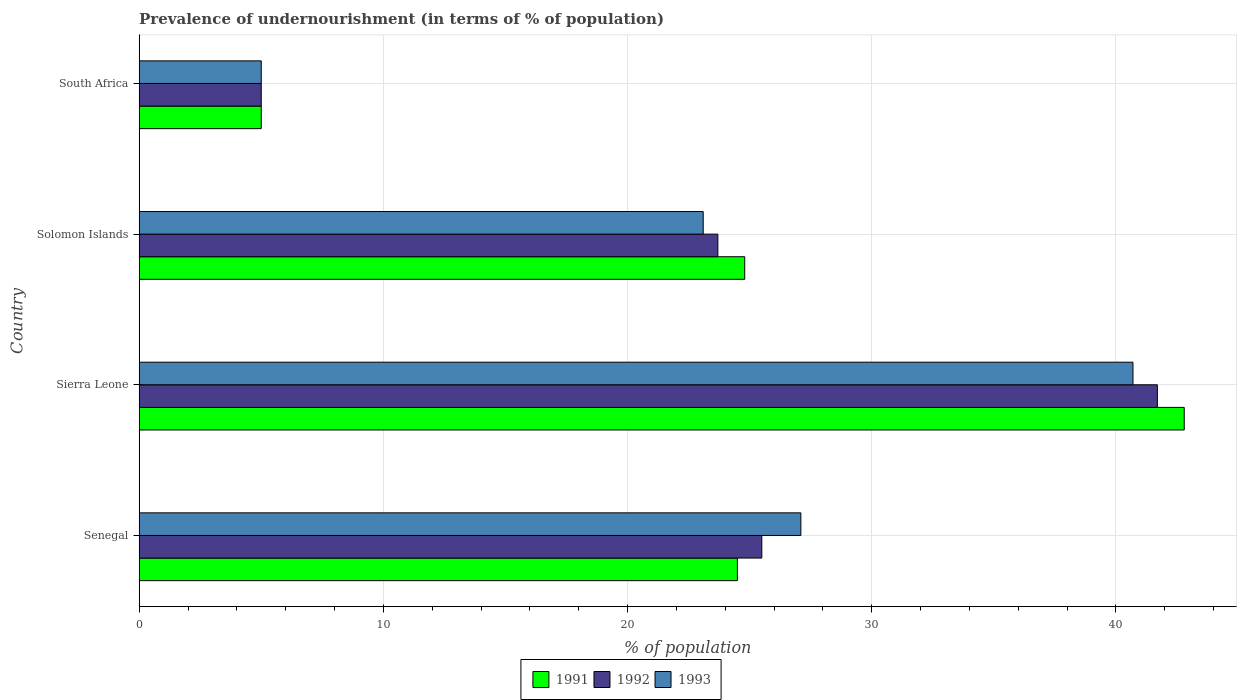How many different coloured bars are there?
Make the answer very short. 3. How many groups of bars are there?
Your answer should be very brief. 4. Are the number of bars on each tick of the Y-axis equal?
Your answer should be very brief. Yes. How many bars are there on the 2nd tick from the top?
Make the answer very short. 3. What is the label of the 3rd group of bars from the top?
Your response must be concise. Sierra Leone. What is the percentage of undernourished population in 1992 in Solomon Islands?
Offer a very short reply. 23.7. Across all countries, what is the maximum percentage of undernourished population in 1991?
Give a very brief answer. 42.8. Across all countries, what is the minimum percentage of undernourished population in 1993?
Offer a very short reply. 5. In which country was the percentage of undernourished population in 1993 maximum?
Offer a very short reply. Sierra Leone. In which country was the percentage of undernourished population in 1992 minimum?
Offer a terse response. South Africa. What is the total percentage of undernourished population in 1991 in the graph?
Keep it short and to the point. 97.1. What is the difference between the percentage of undernourished population in 1991 in Sierra Leone and the percentage of undernourished population in 1993 in Senegal?
Your answer should be very brief. 15.7. What is the average percentage of undernourished population in 1992 per country?
Offer a very short reply. 23.98. What is the difference between the percentage of undernourished population in 1991 and percentage of undernourished population in 1993 in Solomon Islands?
Give a very brief answer. 1.7. In how many countries, is the percentage of undernourished population in 1992 greater than 36 %?
Make the answer very short. 1. What is the ratio of the percentage of undernourished population in 1991 in Senegal to that in Sierra Leone?
Make the answer very short. 0.57. Is the percentage of undernourished population in 1992 in Senegal less than that in Sierra Leone?
Give a very brief answer. Yes. What is the difference between the highest and the second highest percentage of undernourished population in 1993?
Keep it short and to the point. 13.6. What is the difference between the highest and the lowest percentage of undernourished population in 1993?
Keep it short and to the point. 35.7. What does the 3rd bar from the bottom in Sierra Leone represents?
Your answer should be compact. 1993. Is it the case that in every country, the sum of the percentage of undernourished population in 1993 and percentage of undernourished population in 1991 is greater than the percentage of undernourished population in 1992?
Your answer should be very brief. Yes. How many bars are there?
Offer a terse response. 12. How many countries are there in the graph?
Your response must be concise. 4. What is the difference between two consecutive major ticks on the X-axis?
Provide a succinct answer. 10. Does the graph contain grids?
Ensure brevity in your answer.  Yes. Where does the legend appear in the graph?
Offer a terse response. Bottom center. How are the legend labels stacked?
Ensure brevity in your answer.  Horizontal. What is the title of the graph?
Provide a succinct answer. Prevalence of undernourishment (in terms of % of population). Does "2003" appear as one of the legend labels in the graph?
Make the answer very short. No. What is the label or title of the X-axis?
Your response must be concise. % of population. What is the % of population in 1992 in Senegal?
Provide a short and direct response. 25.5. What is the % of population of 1993 in Senegal?
Give a very brief answer. 27.1. What is the % of population in 1991 in Sierra Leone?
Give a very brief answer. 42.8. What is the % of population of 1992 in Sierra Leone?
Ensure brevity in your answer.  41.7. What is the % of population in 1993 in Sierra Leone?
Your answer should be compact. 40.7. What is the % of population of 1991 in Solomon Islands?
Provide a succinct answer. 24.8. What is the % of population in 1992 in Solomon Islands?
Your answer should be very brief. 23.7. What is the % of population of 1993 in Solomon Islands?
Your response must be concise. 23.1. Across all countries, what is the maximum % of population in 1991?
Ensure brevity in your answer.  42.8. Across all countries, what is the maximum % of population of 1992?
Your answer should be compact. 41.7. Across all countries, what is the maximum % of population in 1993?
Make the answer very short. 40.7. Across all countries, what is the minimum % of population in 1991?
Provide a short and direct response. 5. Across all countries, what is the minimum % of population of 1992?
Ensure brevity in your answer.  5. Across all countries, what is the minimum % of population of 1993?
Your answer should be very brief. 5. What is the total % of population in 1991 in the graph?
Make the answer very short. 97.1. What is the total % of population in 1992 in the graph?
Offer a terse response. 95.9. What is the total % of population of 1993 in the graph?
Keep it short and to the point. 95.9. What is the difference between the % of population in 1991 in Senegal and that in Sierra Leone?
Offer a very short reply. -18.3. What is the difference between the % of population of 1992 in Senegal and that in Sierra Leone?
Give a very brief answer. -16.2. What is the difference between the % of population in 1993 in Senegal and that in Sierra Leone?
Offer a very short reply. -13.6. What is the difference between the % of population of 1991 in Senegal and that in South Africa?
Make the answer very short. 19.5. What is the difference between the % of population of 1993 in Senegal and that in South Africa?
Offer a terse response. 22.1. What is the difference between the % of population in 1992 in Sierra Leone and that in Solomon Islands?
Offer a very short reply. 18. What is the difference between the % of population in 1991 in Sierra Leone and that in South Africa?
Give a very brief answer. 37.8. What is the difference between the % of population in 1992 in Sierra Leone and that in South Africa?
Offer a very short reply. 36.7. What is the difference between the % of population of 1993 in Sierra Leone and that in South Africa?
Ensure brevity in your answer.  35.7. What is the difference between the % of population in 1991 in Solomon Islands and that in South Africa?
Your answer should be compact. 19.8. What is the difference between the % of population of 1992 in Solomon Islands and that in South Africa?
Provide a succinct answer. 18.7. What is the difference between the % of population of 1991 in Senegal and the % of population of 1992 in Sierra Leone?
Keep it short and to the point. -17.2. What is the difference between the % of population in 1991 in Senegal and the % of population in 1993 in Sierra Leone?
Keep it short and to the point. -16.2. What is the difference between the % of population of 1992 in Senegal and the % of population of 1993 in Sierra Leone?
Keep it short and to the point. -15.2. What is the difference between the % of population of 1991 in Senegal and the % of population of 1992 in Solomon Islands?
Give a very brief answer. 0.8. What is the difference between the % of population in 1992 in Senegal and the % of population in 1993 in Solomon Islands?
Keep it short and to the point. 2.4. What is the difference between the % of population in 1991 in Senegal and the % of population in 1992 in South Africa?
Give a very brief answer. 19.5. What is the difference between the % of population of 1991 in Senegal and the % of population of 1993 in South Africa?
Make the answer very short. 19.5. What is the difference between the % of population of 1992 in Senegal and the % of population of 1993 in South Africa?
Your answer should be compact. 20.5. What is the difference between the % of population of 1991 in Sierra Leone and the % of population of 1992 in Solomon Islands?
Offer a very short reply. 19.1. What is the difference between the % of population in 1991 in Sierra Leone and the % of population in 1993 in Solomon Islands?
Offer a very short reply. 19.7. What is the difference between the % of population of 1991 in Sierra Leone and the % of population of 1992 in South Africa?
Provide a short and direct response. 37.8. What is the difference between the % of population of 1991 in Sierra Leone and the % of population of 1993 in South Africa?
Offer a very short reply. 37.8. What is the difference between the % of population in 1992 in Sierra Leone and the % of population in 1993 in South Africa?
Offer a terse response. 36.7. What is the difference between the % of population of 1991 in Solomon Islands and the % of population of 1992 in South Africa?
Provide a succinct answer. 19.8. What is the difference between the % of population in 1991 in Solomon Islands and the % of population in 1993 in South Africa?
Keep it short and to the point. 19.8. What is the difference between the % of population of 1992 in Solomon Islands and the % of population of 1993 in South Africa?
Give a very brief answer. 18.7. What is the average % of population of 1991 per country?
Provide a succinct answer. 24.27. What is the average % of population of 1992 per country?
Keep it short and to the point. 23.98. What is the average % of population in 1993 per country?
Offer a terse response. 23.98. What is the difference between the % of population of 1991 and % of population of 1992 in Senegal?
Your answer should be very brief. -1. What is the difference between the % of population of 1991 and % of population of 1993 in Senegal?
Offer a very short reply. -2.6. What is the difference between the % of population in 1992 and % of population in 1993 in Sierra Leone?
Keep it short and to the point. 1. What is the difference between the % of population of 1991 and % of population of 1993 in Solomon Islands?
Provide a short and direct response. 1.7. What is the ratio of the % of population of 1991 in Senegal to that in Sierra Leone?
Make the answer very short. 0.57. What is the ratio of the % of population of 1992 in Senegal to that in Sierra Leone?
Keep it short and to the point. 0.61. What is the ratio of the % of population of 1993 in Senegal to that in Sierra Leone?
Make the answer very short. 0.67. What is the ratio of the % of population in 1991 in Senegal to that in Solomon Islands?
Provide a short and direct response. 0.99. What is the ratio of the % of population in 1992 in Senegal to that in Solomon Islands?
Provide a short and direct response. 1.08. What is the ratio of the % of population of 1993 in Senegal to that in Solomon Islands?
Ensure brevity in your answer.  1.17. What is the ratio of the % of population of 1992 in Senegal to that in South Africa?
Provide a short and direct response. 5.1. What is the ratio of the % of population of 1993 in Senegal to that in South Africa?
Make the answer very short. 5.42. What is the ratio of the % of population in 1991 in Sierra Leone to that in Solomon Islands?
Offer a terse response. 1.73. What is the ratio of the % of population in 1992 in Sierra Leone to that in Solomon Islands?
Keep it short and to the point. 1.76. What is the ratio of the % of population in 1993 in Sierra Leone to that in Solomon Islands?
Your answer should be very brief. 1.76. What is the ratio of the % of population of 1991 in Sierra Leone to that in South Africa?
Offer a very short reply. 8.56. What is the ratio of the % of population of 1992 in Sierra Leone to that in South Africa?
Your answer should be very brief. 8.34. What is the ratio of the % of population of 1993 in Sierra Leone to that in South Africa?
Your answer should be very brief. 8.14. What is the ratio of the % of population in 1991 in Solomon Islands to that in South Africa?
Keep it short and to the point. 4.96. What is the ratio of the % of population in 1992 in Solomon Islands to that in South Africa?
Make the answer very short. 4.74. What is the ratio of the % of population of 1993 in Solomon Islands to that in South Africa?
Give a very brief answer. 4.62. What is the difference between the highest and the lowest % of population of 1991?
Your answer should be very brief. 37.8. What is the difference between the highest and the lowest % of population of 1992?
Provide a succinct answer. 36.7. What is the difference between the highest and the lowest % of population in 1993?
Your answer should be compact. 35.7. 